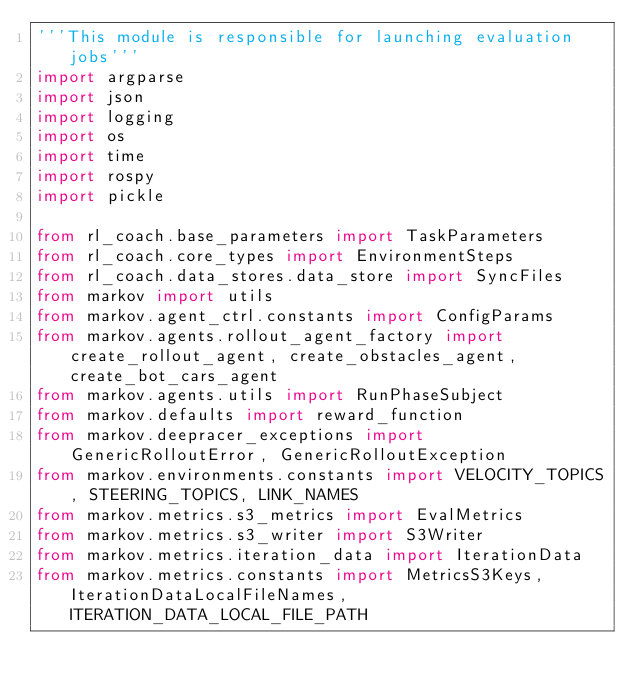Convert code to text. <code><loc_0><loc_0><loc_500><loc_500><_Python_>'''This module is responsible for launching evaluation jobs'''
import argparse
import json
import logging
import os
import time
import rospy
import pickle

from rl_coach.base_parameters import TaskParameters
from rl_coach.core_types import EnvironmentSteps
from rl_coach.data_stores.data_store import SyncFiles
from markov import utils
from markov.agent_ctrl.constants import ConfigParams
from markov.agents.rollout_agent_factory import create_rollout_agent, create_obstacles_agent, create_bot_cars_agent
from markov.agents.utils import RunPhaseSubject
from markov.defaults import reward_function
from markov.deepracer_exceptions import GenericRolloutError, GenericRolloutException
from markov.environments.constants import VELOCITY_TOPICS, STEERING_TOPICS, LINK_NAMES
from markov.metrics.s3_metrics import EvalMetrics
from markov.metrics.s3_writer import S3Writer
from markov.metrics.iteration_data import IterationData
from markov.metrics.constants import MetricsS3Keys, IterationDataLocalFileNames, ITERATION_DATA_LOCAL_FILE_PATH</code> 